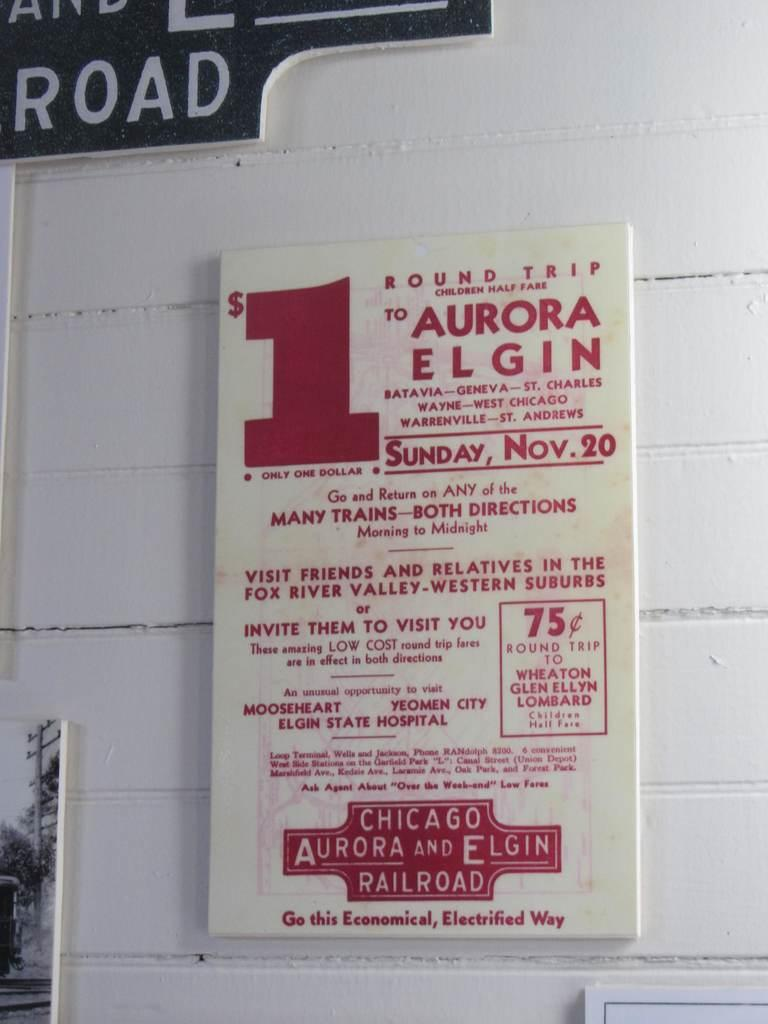<image>
Render a clear and concise summary of the photo. White and red sign on the wall for Chicago Aurora and Elgin Railroads. 